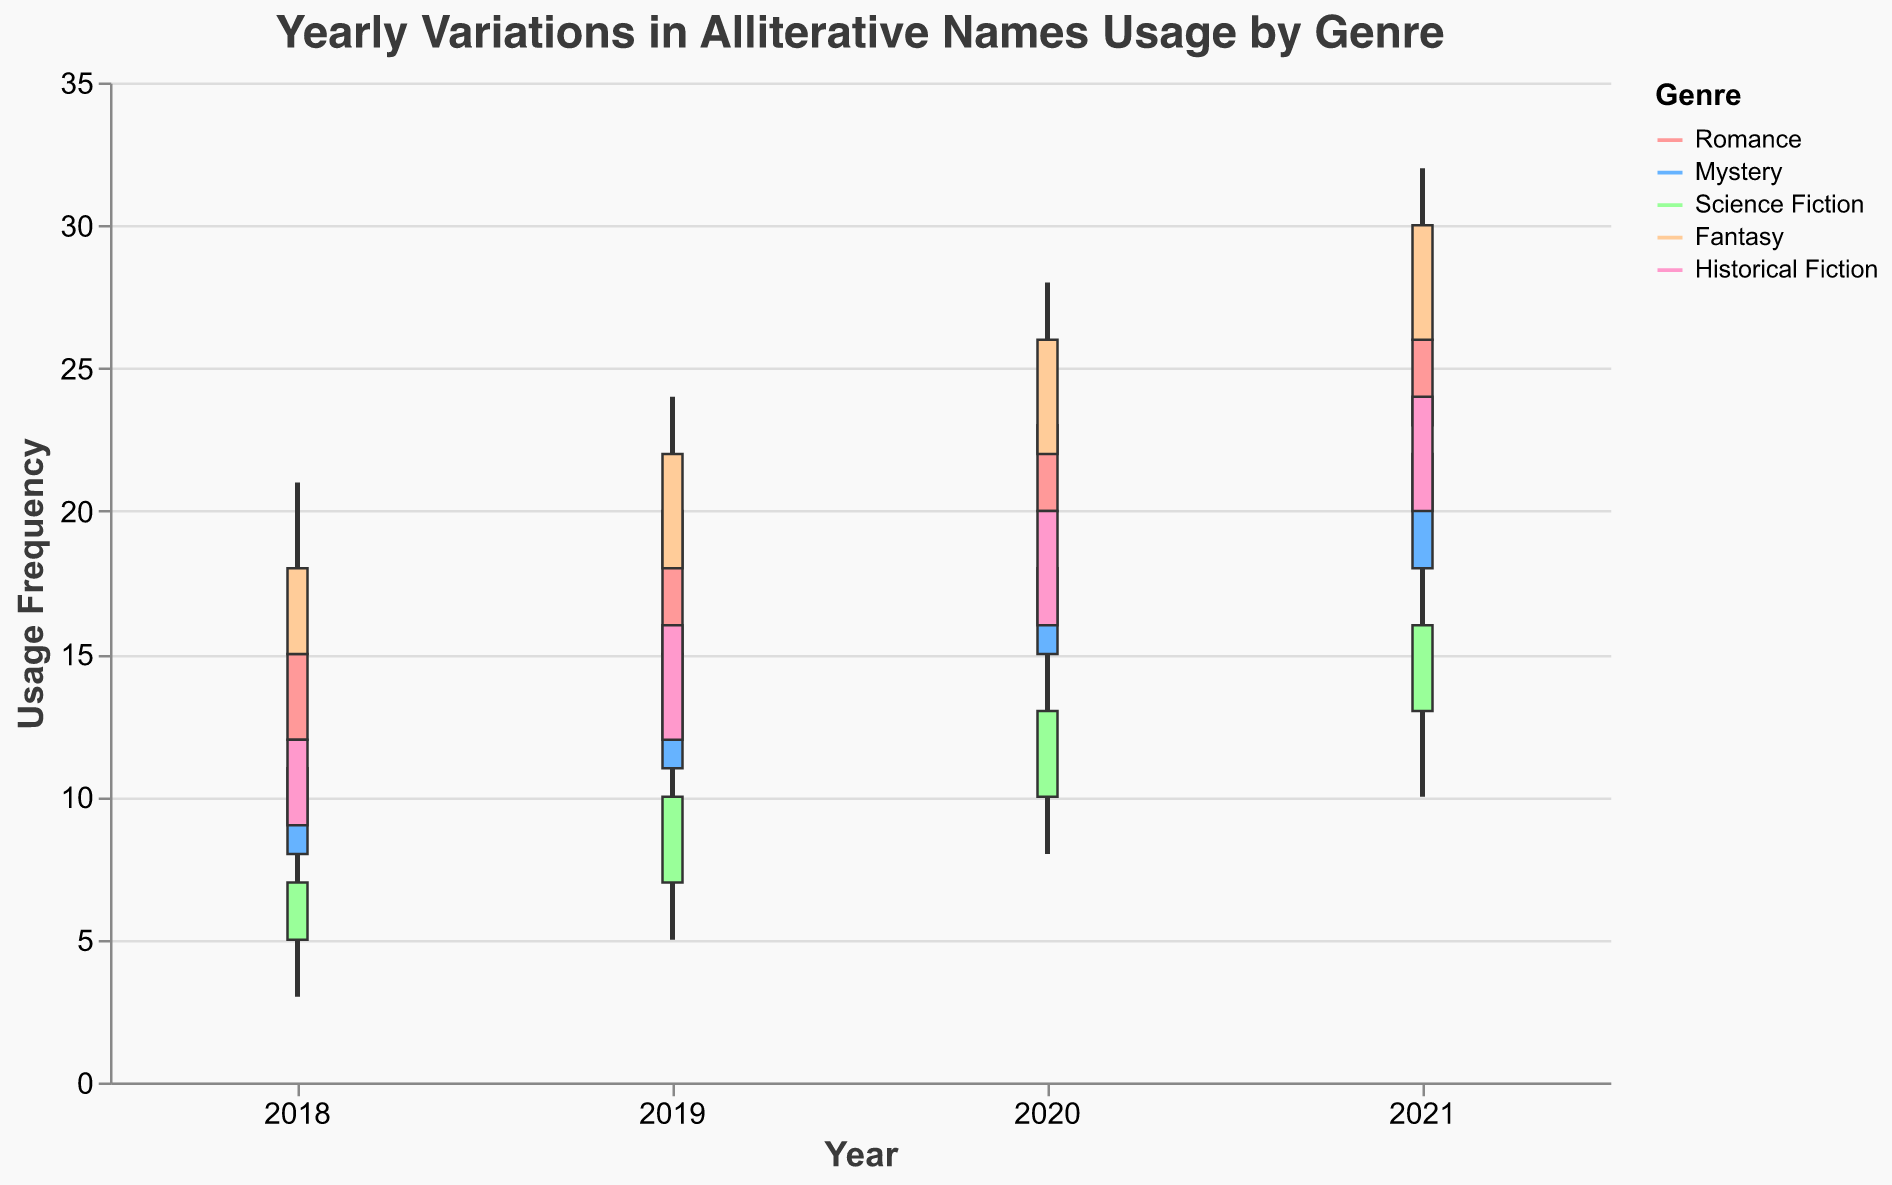How many genres are represented in the data? The figure contains a legend that lists all the represented genres. By counting those, we can determine the number of genres.
Answer: 5 Which genre had the highest variation in alliterative name usage in 2020? To find the highest variation, we look at the difference between the high and low values for each genre in 2020. The genre with the largest difference is the one with the highest variation. The differences are 8 for Romance, 9 for Mystery, 7 for Science Fiction, 9 for Fantasy, and 9 for Historical Fiction.
Answer: Mystery, Fantasy, Historical Fiction What was the lowest usage of alliterative names in Romance for any year? To find the lowest usage in Romance, we look at the "Low" values for Romance across all years (9, 13, 17, 19). The minimum of these values is 9.
Answer: 9 Which genre shows the most significant increase in the "Close" value from 2018 to 2021? Calculate the difference in the "Close" value from 2018 to 2021 for each genre: Romance (26-15=11), Mystery (22-11=11), Science Fiction (16-7=9), Fantasy (30-18=12), and Historical Fiction (24-12=12). The genre with the highest increase is determined by comparing these values.
Answer: Fantasy and Historical Fiction In 2019, which genre had the highest "High" value and what was it? For 2019, check the "High" values across all genres: Romance (22), Mystery (17), Science Fiction (12), Fantasy (24), Historical Fiction (18). The highest value among these is 24 in Fantasy.
Answer: Fantasy, 24 How did the "Open" value for Historical Fiction change from 2018 to 2021? To find the change in the "Open" value, subtract the value in 2018 from that in 2021 for Historical Fiction (20-9).
Answer: Increased by 11 Which year had the highest average "Close" value across all genres? To find the average "Close" value for each year, sum the "Close" values for all genres in that year and divide by the number of genres (5). The calculations are: 
2018: (15+11+7+18+12)/5 = 12.6, 
2019: (20+15+10+22+16)/5 = 16.6,
2020: (23+18+13+26+20)/5 = 20,
2021: (26+22+16+30+24)/5 = 23.6.
Answer: 2021 What trend is observed in the usage frequency of alliterative names in Science Fiction from 2018 to 2021? To identify the trend in Science Fiction, look at the "Close" values for each year (7, 10, 13, 16). The values show a consistent increase over the years.
Answer: Increasing trend 